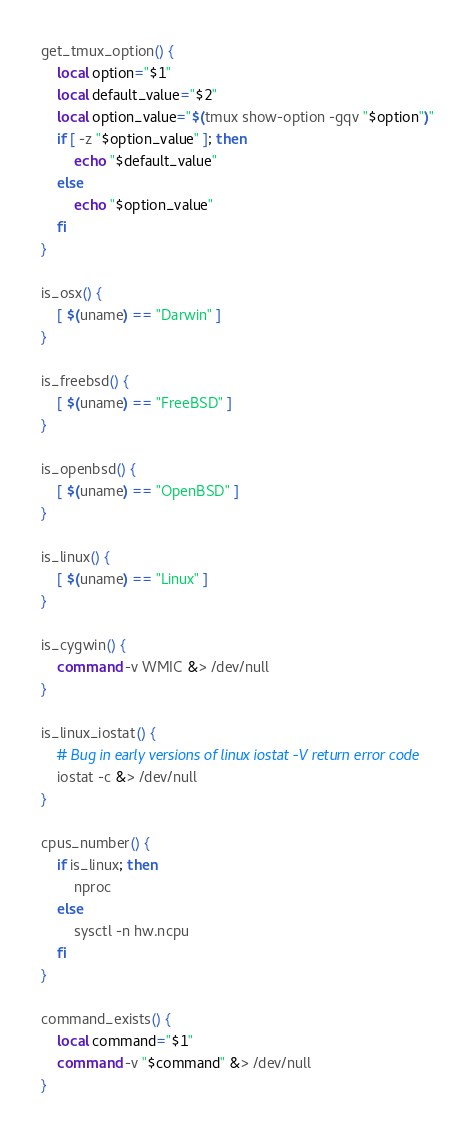Convert code to text. <code><loc_0><loc_0><loc_500><loc_500><_Bash_>get_tmux_option() {
	local option="$1"
	local default_value="$2"
	local option_value="$(tmux show-option -gqv "$option")"
	if [ -z "$option_value" ]; then
		echo "$default_value"
	else
		echo "$option_value"
	fi
}

is_osx() {
	[ $(uname) == "Darwin" ]
}

is_freebsd() {
	[ $(uname) == "FreeBSD" ]
}

is_openbsd() {
	[ $(uname) == "OpenBSD" ]
}

is_linux() {
	[ $(uname) == "Linux" ]
}

is_cygwin() {
	command -v WMIC &> /dev/null
}

is_linux_iostat() {
	# Bug in early versions of linux iostat -V return error code
	iostat -c &> /dev/null
}

cpus_number() {
	if is_linux; then
		nproc
	else
		sysctl -n hw.ncpu
	fi
}

command_exists() {
	local command="$1"
	command -v "$command" &> /dev/null
}
</code> 